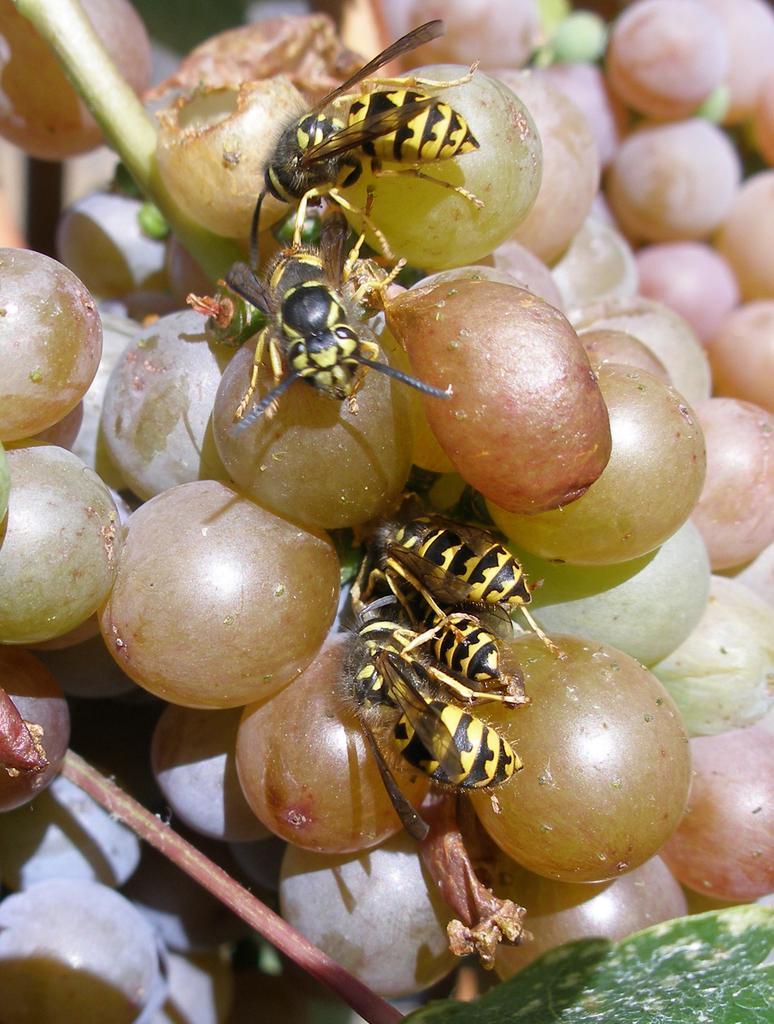In one or two sentences, can you explain what this image depicts? Here in this picture we can see a bunch of grapes present over a place and on that we can see some bees present. 